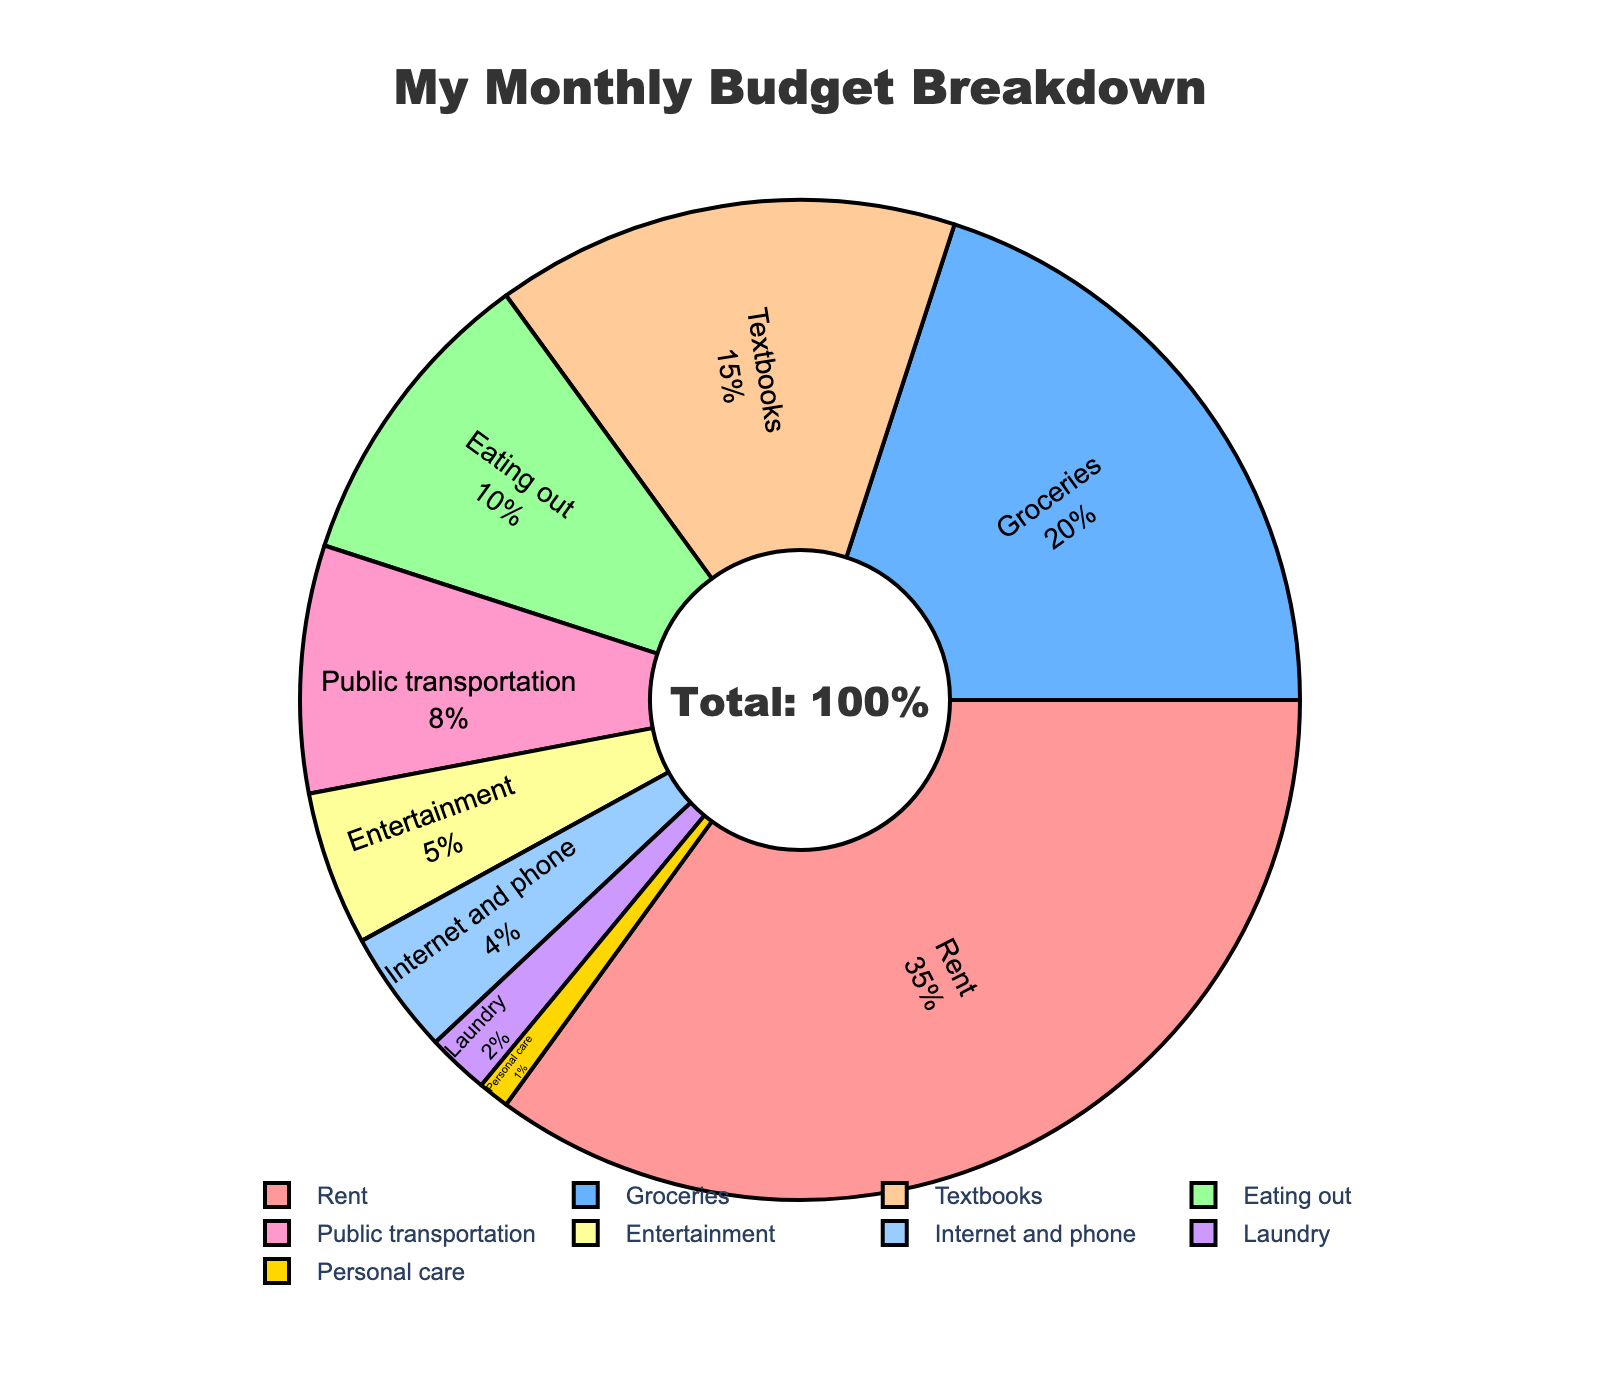What is the largest expense category in the student's monthly budget? The largest expense category is identified by the slice with the highest percentage. Rent occupies 35% of the budget, which is the highest.
Answer: Rent How much more is spent on textbooks compared to groceries? The percentage for textbooks is 15%, and groceries is 20%. To find the difference, subtract the percentage for textbooks from groceries: \(20\% - 15\% = 5\%\).
Answer: 5% What is the combined percentage for eating out and entertainment? The percentage for eating out is 10% and entertainment is 5%. Adding them together gives: \(10\% + 5\% = 15\%\).
Answer: 15% Which category takes up less of the budget: public transportation or internet and phone? Public transportation occupies 8% of the budget, while internet and phone take up 4%. Thus, internet and phone is the smaller expense.
Answer: Internet and phone How does the percentage spent on rent compare to the total percentage spent on groceries, eating out, and laundry combined? Add the percentages for groceries (20%), eating out (10%), and laundry (2%): \(20\% + 10\% + 2\% = 32\%\). Rent is 35%, which is greater.
Answer: Rent is greater What is the combined percentage for personal care and laundry? Personal care is 1%, and laundry is 2%. The sum of these percentages is \(1\% + 2\% = 3\%\).
Answer: 3% Which category is represented by the light blue slice? The light blue slice is used to visually identify a specific category. The light blue slice represents groceries.
Answer: Groceries What is the percentage difference between the highest and lowest expense categories? The highest expense is rent at 35%, and the lowest is personal care at 1%. The difference is \(35\% - 1\% = 34\%\).
Answer: 34% Is the combined percentage of public transportation and entertainment greater than food spent on eating out? Public transportation is 8% and entertainment is 5%. Combined they are \(8\% + 5\% = 13\%\). Eating out is 10%, so 13% is greater than 10%.
Answer: Yes What percentage of the budget goes to internet and phone plus entertainment? Internet and phone take up 4%, and entertainment 5%. Adding these together gives \(4\% + 5\% = 9\%\).
Answer: 9% 